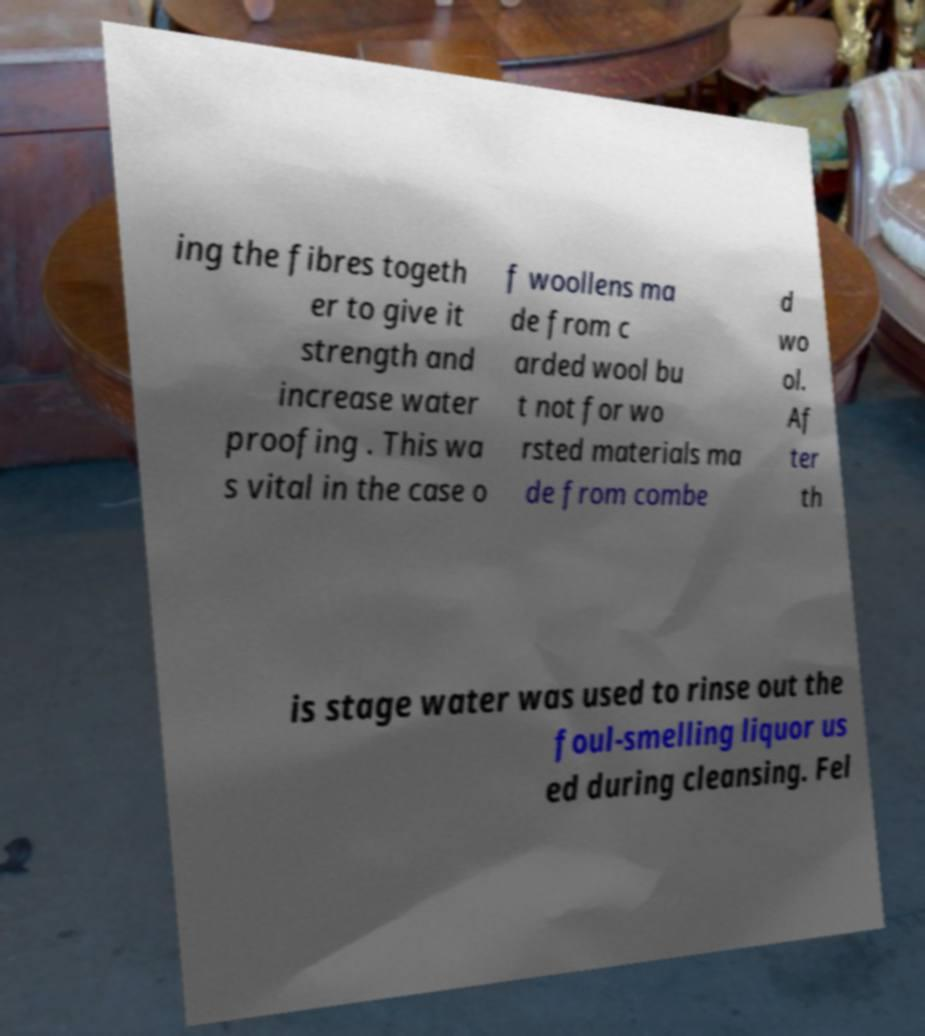Can you accurately transcribe the text from the provided image for me? ing the fibres togeth er to give it strength and increase water proofing . This wa s vital in the case o f woollens ma de from c arded wool bu t not for wo rsted materials ma de from combe d wo ol. Af ter th is stage water was used to rinse out the foul-smelling liquor us ed during cleansing. Fel 